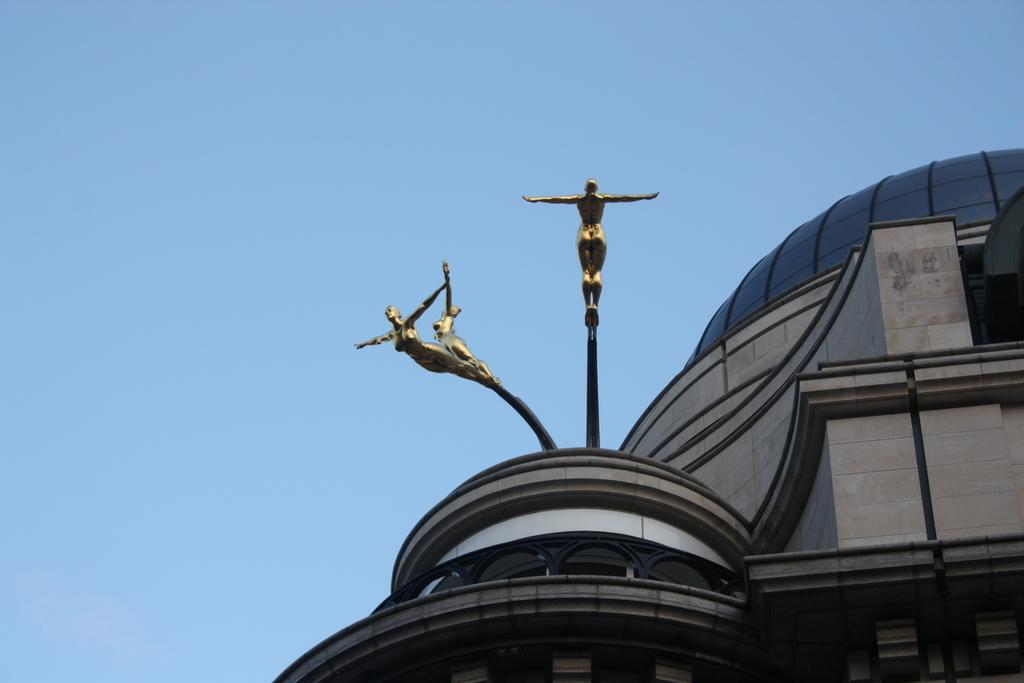What type of structure is present in the image? There is a building in the image. What is the color of the building? The building is brown in color. What other objects are attached to poles in the image? There are statues attached to poles in the image. What can be seen in the background of the image? The sky is blue in the background of the image. Can you tell me how many dogs are present in the image? There are no dogs present in the image. What type of connection can be seen between the building and the statues in the image? There is no visible connection between the building and the statues in the image; they are simply located near each other. 